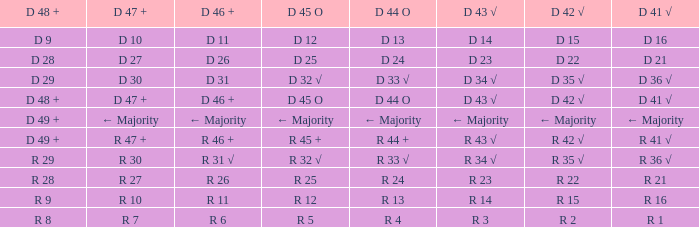What is the value of D 43 √ when the value of D 42 √ is d 42 √? D 43 √. 